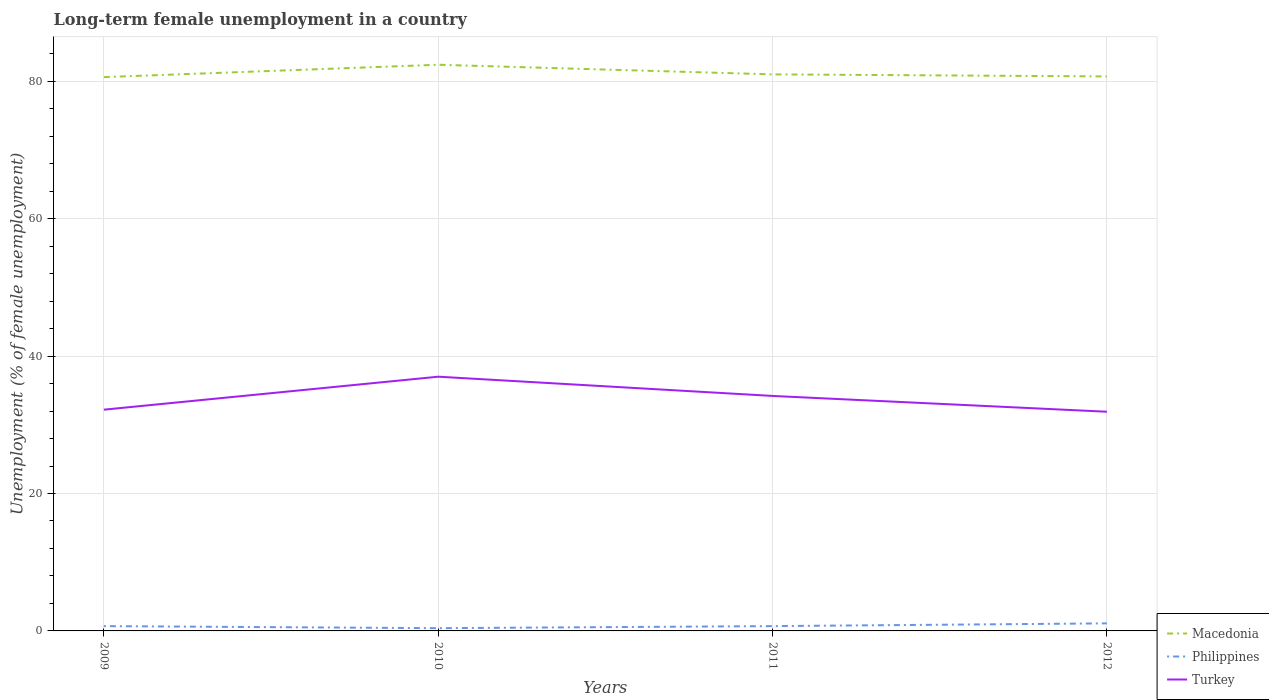How many different coloured lines are there?
Offer a very short reply. 3. Across all years, what is the maximum percentage of long-term unemployed female population in Macedonia?
Provide a short and direct response. 80.6. What is the total percentage of long-term unemployed female population in Turkey in the graph?
Your response must be concise. 0.3. What is the difference between the highest and the second highest percentage of long-term unemployed female population in Macedonia?
Keep it short and to the point. 1.8. What is the difference between the highest and the lowest percentage of long-term unemployed female population in Macedonia?
Ensure brevity in your answer.  1. How many years are there in the graph?
Offer a very short reply. 4. What is the difference between two consecutive major ticks on the Y-axis?
Give a very brief answer. 20. Does the graph contain any zero values?
Make the answer very short. No. How many legend labels are there?
Offer a terse response. 3. How are the legend labels stacked?
Keep it short and to the point. Vertical. What is the title of the graph?
Make the answer very short. Long-term female unemployment in a country. What is the label or title of the Y-axis?
Offer a terse response. Unemployment (% of female unemployment). What is the Unemployment (% of female unemployment) of Macedonia in 2009?
Offer a terse response. 80.6. What is the Unemployment (% of female unemployment) in Philippines in 2009?
Give a very brief answer. 0.7. What is the Unemployment (% of female unemployment) of Turkey in 2009?
Offer a terse response. 32.2. What is the Unemployment (% of female unemployment) of Macedonia in 2010?
Keep it short and to the point. 82.4. What is the Unemployment (% of female unemployment) in Philippines in 2010?
Offer a very short reply. 0.4. What is the Unemployment (% of female unemployment) in Turkey in 2010?
Your response must be concise. 37. What is the Unemployment (% of female unemployment) of Macedonia in 2011?
Keep it short and to the point. 81. What is the Unemployment (% of female unemployment) in Philippines in 2011?
Ensure brevity in your answer.  0.7. What is the Unemployment (% of female unemployment) in Turkey in 2011?
Offer a very short reply. 34.2. What is the Unemployment (% of female unemployment) of Macedonia in 2012?
Offer a terse response. 80.7. What is the Unemployment (% of female unemployment) of Philippines in 2012?
Keep it short and to the point. 1.1. What is the Unemployment (% of female unemployment) of Turkey in 2012?
Offer a terse response. 31.9. Across all years, what is the maximum Unemployment (% of female unemployment) of Macedonia?
Your response must be concise. 82.4. Across all years, what is the maximum Unemployment (% of female unemployment) in Philippines?
Offer a terse response. 1.1. Across all years, what is the maximum Unemployment (% of female unemployment) of Turkey?
Keep it short and to the point. 37. Across all years, what is the minimum Unemployment (% of female unemployment) in Macedonia?
Make the answer very short. 80.6. Across all years, what is the minimum Unemployment (% of female unemployment) in Philippines?
Your response must be concise. 0.4. Across all years, what is the minimum Unemployment (% of female unemployment) of Turkey?
Your response must be concise. 31.9. What is the total Unemployment (% of female unemployment) of Macedonia in the graph?
Provide a succinct answer. 324.7. What is the total Unemployment (% of female unemployment) in Philippines in the graph?
Provide a succinct answer. 2.9. What is the total Unemployment (% of female unemployment) of Turkey in the graph?
Offer a very short reply. 135.3. What is the difference between the Unemployment (% of female unemployment) of Philippines in 2009 and that in 2010?
Provide a succinct answer. 0.3. What is the difference between the Unemployment (% of female unemployment) in Macedonia in 2009 and that in 2012?
Ensure brevity in your answer.  -0.1. What is the difference between the Unemployment (% of female unemployment) of Philippines in 2009 and that in 2012?
Your response must be concise. -0.4. What is the difference between the Unemployment (% of female unemployment) in Turkey in 2010 and that in 2011?
Keep it short and to the point. 2.8. What is the difference between the Unemployment (% of female unemployment) in Macedonia in 2010 and that in 2012?
Keep it short and to the point. 1.7. What is the difference between the Unemployment (% of female unemployment) of Philippines in 2010 and that in 2012?
Provide a succinct answer. -0.7. What is the difference between the Unemployment (% of female unemployment) in Turkey in 2010 and that in 2012?
Offer a terse response. 5.1. What is the difference between the Unemployment (% of female unemployment) in Macedonia in 2011 and that in 2012?
Give a very brief answer. 0.3. What is the difference between the Unemployment (% of female unemployment) in Macedonia in 2009 and the Unemployment (% of female unemployment) in Philippines in 2010?
Offer a very short reply. 80.2. What is the difference between the Unemployment (% of female unemployment) of Macedonia in 2009 and the Unemployment (% of female unemployment) of Turkey in 2010?
Give a very brief answer. 43.6. What is the difference between the Unemployment (% of female unemployment) in Philippines in 2009 and the Unemployment (% of female unemployment) in Turkey in 2010?
Your answer should be compact. -36.3. What is the difference between the Unemployment (% of female unemployment) of Macedonia in 2009 and the Unemployment (% of female unemployment) of Philippines in 2011?
Keep it short and to the point. 79.9. What is the difference between the Unemployment (% of female unemployment) of Macedonia in 2009 and the Unemployment (% of female unemployment) of Turkey in 2011?
Provide a succinct answer. 46.4. What is the difference between the Unemployment (% of female unemployment) of Philippines in 2009 and the Unemployment (% of female unemployment) of Turkey in 2011?
Your response must be concise. -33.5. What is the difference between the Unemployment (% of female unemployment) of Macedonia in 2009 and the Unemployment (% of female unemployment) of Philippines in 2012?
Make the answer very short. 79.5. What is the difference between the Unemployment (% of female unemployment) in Macedonia in 2009 and the Unemployment (% of female unemployment) in Turkey in 2012?
Give a very brief answer. 48.7. What is the difference between the Unemployment (% of female unemployment) in Philippines in 2009 and the Unemployment (% of female unemployment) in Turkey in 2012?
Your answer should be compact. -31.2. What is the difference between the Unemployment (% of female unemployment) of Macedonia in 2010 and the Unemployment (% of female unemployment) of Philippines in 2011?
Offer a very short reply. 81.7. What is the difference between the Unemployment (% of female unemployment) of Macedonia in 2010 and the Unemployment (% of female unemployment) of Turkey in 2011?
Ensure brevity in your answer.  48.2. What is the difference between the Unemployment (% of female unemployment) of Philippines in 2010 and the Unemployment (% of female unemployment) of Turkey in 2011?
Give a very brief answer. -33.8. What is the difference between the Unemployment (% of female unemployment) of Macedonia in 2010 and the Unemployment (% of female unemployment) of Philippines in 2012?
Your response must be concise. 81.3. What is the difference between the Unemployment (% of female unemployment) of Macedonia in 2010 and the Unemployment (% of female unemployment) of Turkey in 2012?
Keep it short and to the point. 50.5. What is the difference between the Unemployment (% of female unemployment) of Philippines in 2010 and the Unemployment (% of female unemployment) of Turkey in 2012?
Offer a terse response. -31.5. What is the difference between the Unemployment (% of female unemployment) in Macedonia in 2011 and the Unemployment (% of female unemployment) in Philippines in 2012?
Give a very brief answer. 79.9. What is the difference between the Unemployment (% of female unemployment) in Macedonia in 2011 and the Unemployment (% of female unemployment) in Turkey in 2012?
Provide a short and direct response. 49.1. What is the difference between the Unemployment (% of female unemployment) in Philippines in 2011 and the Unemployment (% of female unemployment) in Turkey in 2012?
Provide a short and direct response. -31.2. What is the average Unemployment (% of female unemployment) in Macedonia per year?
Ensure brevity in your answer.  81.17. What is the average Unemployment (% of female unemployment) in Philippines per year?
Provide a succinct answer. 0.72. What is the average Unemployment (% of female unemployment) of Turkey per year?
Provide a short and direct response. 33.83. In the year 2009, what is the difference between the Unemployment (% of female unemployment) of Macedonia and Unemployment (% of female unemployment) of Philippines?
Offer a very short reply. 79.9. In the year 2009, what is the difference between the Unemployment (% of female unemployment) in Macedonia and Unemployment (% of female unemployment) in Turkey?
Make the answer very short. 48.4. In the year 2009, what is the difference between the Unemployment (% of female unemployment) in Philippines and Unemployment (% of female unemployment) in Turkey?
Your response must be concise. -31.5. In the year 2010, what is the difference between the Unemployment (% of female unemployment) in Macedonia and Unemployment (% of female unemployment) in Philippines?
Give a very brief answer. 82. In the year 2010, what is the difference between the Unemployment (% of female unemployment) of Macedonia and Unemployment (% of female unemployment) of Turkey?
Offer a very short reply. 45.4. In the year 2010, what is the difference between the Unemployment (% of female unemployment) of Philippines and Unemployment (% of female unemployment) of Turkey?
Provide a short and direct response. -36.6. In the year 2011, what is the difference between the Unemployment (% of female unemployment) of Macedonia and Unemployment (% of female unemployment) of Philippines?
Offer a very short reply. 80.3. In the year 2011, what is the difference between the Unemployment (% of female unemployment) of Macedonia and Unemployment (% of female unemployment) of Turkey?
Keep it short and to the point. 46.8. In the year 2011, what is the difference between the Unemployment (% of female unemployment) in Philippines and Unemployment (% of female unemployment) in Turkey?
Your answer should be very brief. -33.5. In the year 2012, what is the difference between the Unemployment (% of female unemployment) of Macedonia and Unemployment (% of female unemployment) of Philippines?
Provide a succinct answer. 79.6. In the year 2012, what is the difference between the Unemployment (% of female unemployment) in Macedonia and Unemployment (% of female unemployment) in Turkey?
Keep it short and to the point. 48.8. In the year 2012, what is the difference between the Unemployment (% of female unemployment) in Philippines and Unemployment (% of female unemployment) in Turkey?
Your answer should be compact. -30.8. What is the ratio of the Unemployment (% of female unemployment) of Macedonia in 2009 to that in 2010?
Provide a short and direct response. 0.98. What is the ratio of the Unemployment (% of female unemployment) of Turkey in 2009 to that in 2010?
Keep it short and to the point. 0.87. What is the ratio of the Unemployment (% of female unemployment) of Turkey in 2009 to that in 2011?
Give a very brief answer. 0.94. What is the ratio of the Unemployment (% of female unemployment) in Macedonia in 2009 to that in 2012?
Your answer should be compact. 1. What is the ratio of the Unemployment (% of female unemployment) in Philippines in 2009 to that in 2012?
Provide a short and direct response. 0.64. What is the ratio of the Unemployment (% of female unemployment) of Turkey in 2009 to that in 2012?
Your answer should be compact. 1.01. What is the ratio of the Unemployment (% of female unemployment) of Macedonia in 2010 to that in 2011?
Your response must be concise. 1.02. What is the ratio of the Unemployment (% of female unemployment) in Philippines in 2010 to that in 2011?
Your response must be concise. 0.57. What is the ratio of the Unemployment (% of female unemployment) in Turkey in 2010 to that in 2011?
Offer a very short reply. 1.08. What is the ratio of the Unemployment (% of female unemployment) in Macedonia in 2010 to that in 2012?
Keep it short and to the point. 1.02. What is the ratio of the Unemployment (% of female unemployment) of Philippines in 2010 to that in 2012?
Your answer should be very brief. 0.36. What is the ratio of the Unemployment (% of female unemployment) of Turkey in 2010 to that in 2012?
Keep it short and to the point. 1.16. What is the ratio of the Unemployment (% of female unemployment) in Macedonia in 2011 to that in 2012?
Your answer should be very brief. 1. What is the ratio of the Unemployment (% of female unemployment) of Philippines in 2011 to that in 2012?
Ensure brevity in your answer.  0.64. What is the ratio of the Unemployment (% of female unemployment) in Turkey in 2011 to that in 2012?
Your answer should be compact. 1.07. What is the difference between the highest and the second highest Unemployment (% of female unemployment) of Philippines?
Provide a succinct answer. 0.4. What is the difference between the highest and the second highest Unemployment (% of female unemployment) of Turkey?
Ensure brevity in your answer.  2.8. What is the difference between the highest and the lowest Unemployment (% of female unemployment) in Macedonia?
Ensure brevity in your answer.  1.8. What is the difference between the highest and the lowest Unemployment (% of female unemployment) in Turkey?
Keep it short and to the point. 5.1. 